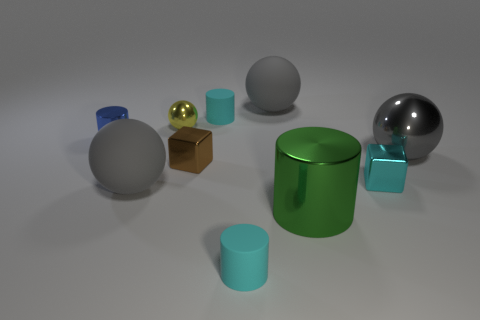Is the shape of the tiny cyan metallic thing the same as the blue shiny thing?
Keep it short and to the point. No. How many other things are the same shape as the big green shiny object?
Your answer should be compact. 3. There is a ball that is the same size as the cyan metal thing; what is its color?
Make the answer very short. Yellow. Are there the same number of small blue things left of the gray metallic sphere and tiny balls?
Offer a terse response. Yes. What is the shape of the shiny thing that is in front of the small metal ball and on the left side of the brown shiny cube?
Offer a very short reply. Cylinder. Do the blue thing and the yellow metallic ball have the same size?
Keep it short and to the point. Yes. Is there a gray ball that has the same material as the green thing?
Give a very brief answer. Yes. What number of rubber cylinders are both in front of the tiny brown block and behind the gray metallic ball?
Give a very brief answer. 0. What is the cyan cylinder that is in front of the gray metallic object made of?
Ensure brevity in your answer.  Rubber. What number of small metallic things are the same color as the big shiny sphere?
Offer a terse response. 0. 